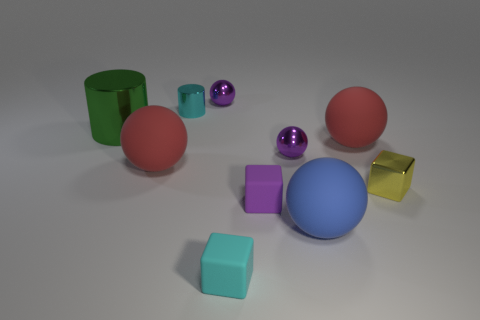How many other small objects have the same shape as the tiny cyan matte thing?
Offer a terse response. 2. Is the color of the cube that is in front of the big blue thing the same as the small cylinder that is left of the tiny purple cube?
Offer a very short reply. Yes. There is a blue thing that is the same size as the green cylinder; what is it made of?
Provide a succinct answer. Rubber. Are there any matte things of the same size as the yellow metal cube?
Your answer should be very brief. Yes. Are there fewer tiny yellow metallic blocks that are right of the yellow object than blue matte cylinders?
Provide a succinct answer. No. Is the number of red spheres to the left of the purple matte block less than the number of small objects on the left side of the large blue rubber thing?
Keep it short and to the point. Yes. How many balls are either big matte things or small matte things?
Provide a succinct answer. 3. Are the cyan object that is behind the small cyan cube and the tiny cyan block in front of the small cyan shiny thing made of the same material?
Make the answer very short. No. What is the shape of the green shiny object that is the same size as the blue thing?
Offer a terse response. Cylinder. How many other objects are the same color as the small cylinder?
Provide a short and direct response. 1. 